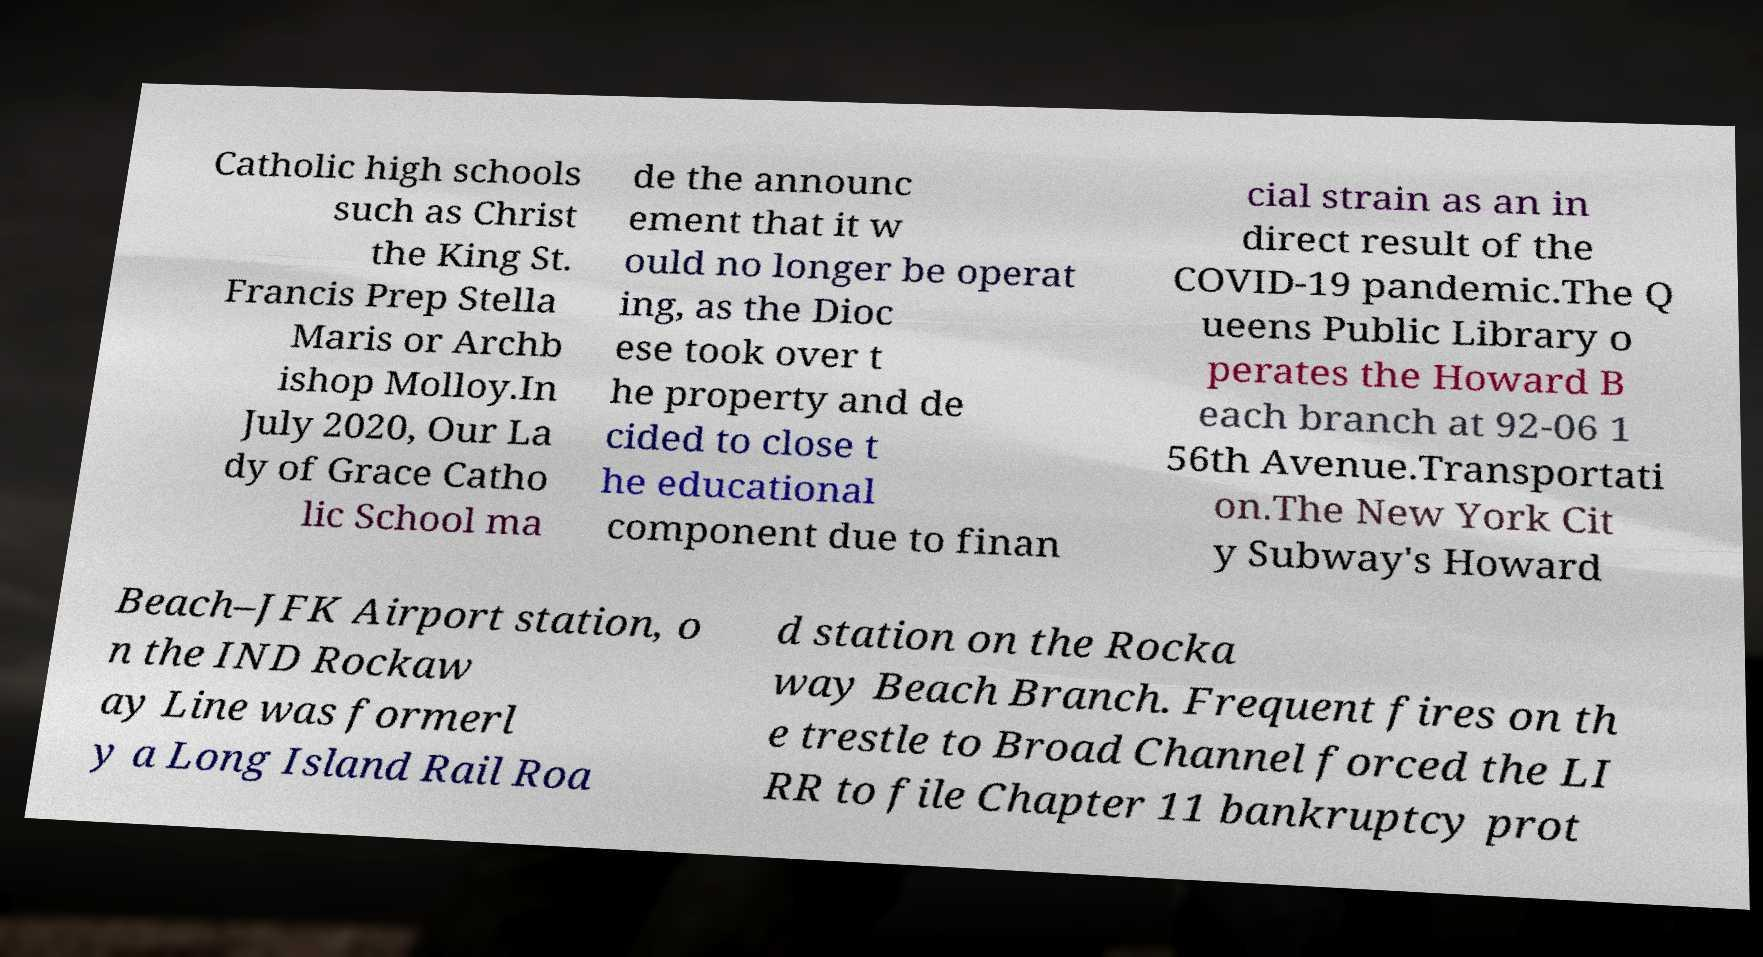Could you extract and type out the text from this image? Catholic high schools such as Christ the King St. Francis Prep Stella Maris or Archb ishop Molloy.In July 2020, Our La dy of Grace Catho lic School ma de the announc ement that it w ould no longer be operat ing, as the Dioc ese took over t he property and de cided to close t he educational component due to finan cial strain as an in direct result of the COVID-19 pandemic.The Q ueens Public Library o perates the Howard B each branch at 92-06 1 56th Avenue.Transportati on.The New York Cit y Subway's Howard Beach–JFK Airport station, o n the IND Rockaw ay Line was formerl y a Long Island Rail Roa d station on the Rocka way Beach Branch. Frequent fires on th e trestle to Broad Channel forced the LI RR to file Chapter 11 bankruptcy prot 